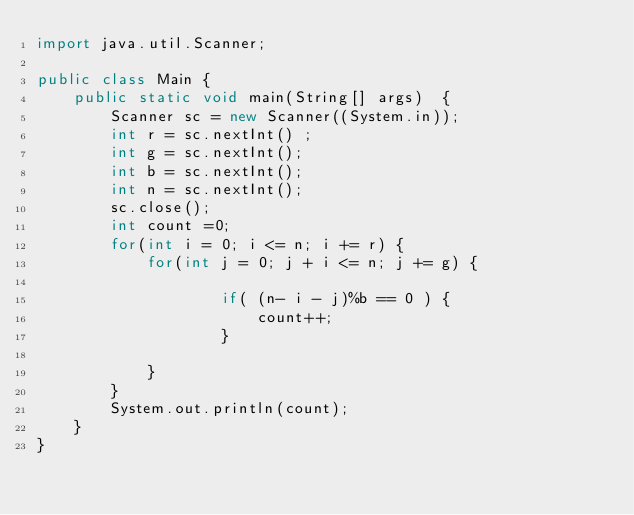<code> <loc_0><loc_0><loc_500><loc_500><_Java_>import java.util.Scanner;

public class Main {
	public static void main(String[] args)  {
		Scanner sc = new Scanner((System.in));
		int r = sc.nextInt() ;
		int g = sc.nextInt();
		int b = sc.nextInt();
		int n = sc.nextInt();
		sc.close();
		int count =0;
		for(int i = 0; i <= n; i += r) {
			for(int j = 0; j + i <= n; j += g) {

					if( (n- i - j)%b == 0 ) {
						count++;
					}

			}
		}
		System.out.println(count);
	}
}</code> 